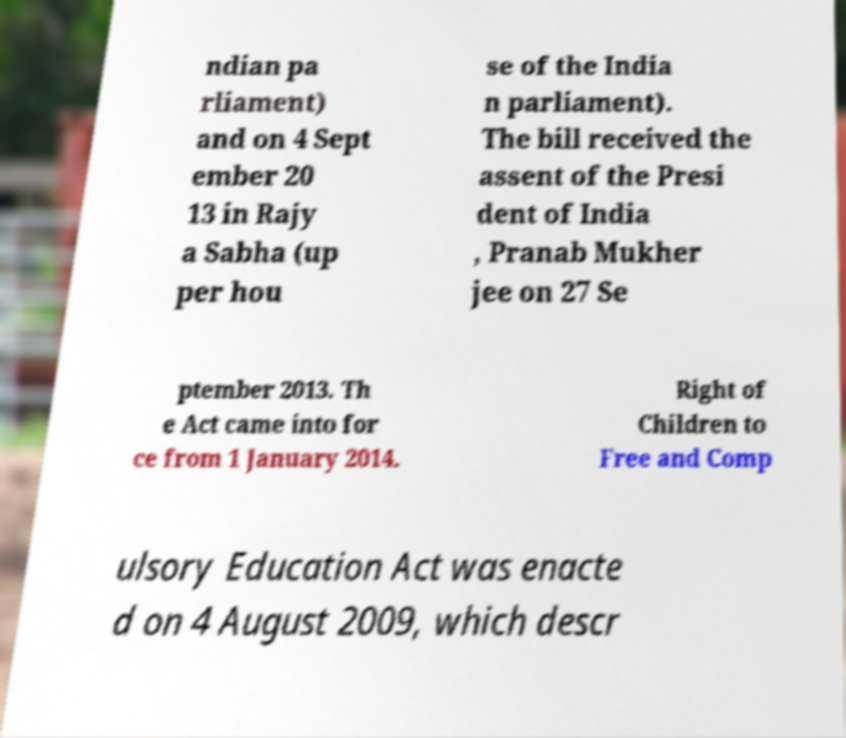For documentation purposes, I need the text within this image transcribed. Could you provide that? ndian pa rliament) and on 4 Sept ember 20 13 in Rajy a Sabha (up per hou se of the India n parliament). The bill received the assent of the Presi dent of India , Pranab Mukher jee on 27 Se ptember 2013. Th e Act came into for ce from 1 January 2014. Right of Children to Free and Comp ulsory Education Act was enacte d on 4 August 2009, which descr 